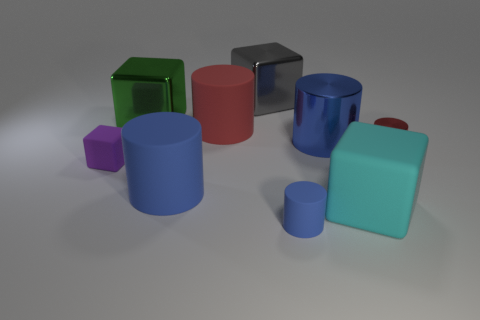How many rubber objects are the same size as the red metallic object?
Keep it short and to the point. 2. Is the tiny cylinder that is behind the purple block made of the same material as the tiny blue cylinder?
Offer a terse response. No. Are there any red things?
Your answer should be very brief. Yes. There is a red thing that is made of the same material as the purple object; what is its size?
Keep it short and to the point. Large. Are there any large objects that have the same color as the big metallic cylinder?
Offer a terse response. Yes. Does the big metal thing right of the big gray shiny cube have the same color as the tiny rubber object right of the gray metal block?
Ensure brevity in your answer.  Yes. The metal thing that is the same color as the small rubber cylinder is what size?
Give a very brief answer. Large. Is there a big purple object that has the same material as the green object?
Make the answer very short. No. What color is the small rubber cube?
Provide a succinct answer. Purple. There is a metal cylinder to the left of the red object in front of the large cylinder to the right of the small blue thing; what is its size?
Offer a very short reply. Large. 